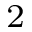Convert formula to latex. <formula><loc_0><loc_0><loc_500><loc_500>^ { 2 }</formula> 